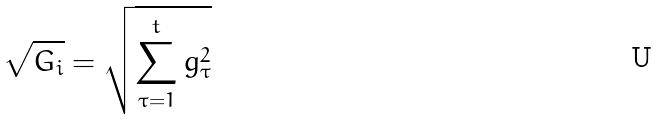<formula> <loc_0><loc_0><loc_500><loc_500>\sqrt { G _ { i } } = \sqrt { \sum _ { \tau = 1 } ^ { t } g _ { \tau } ^ { 2 } }</formula> 